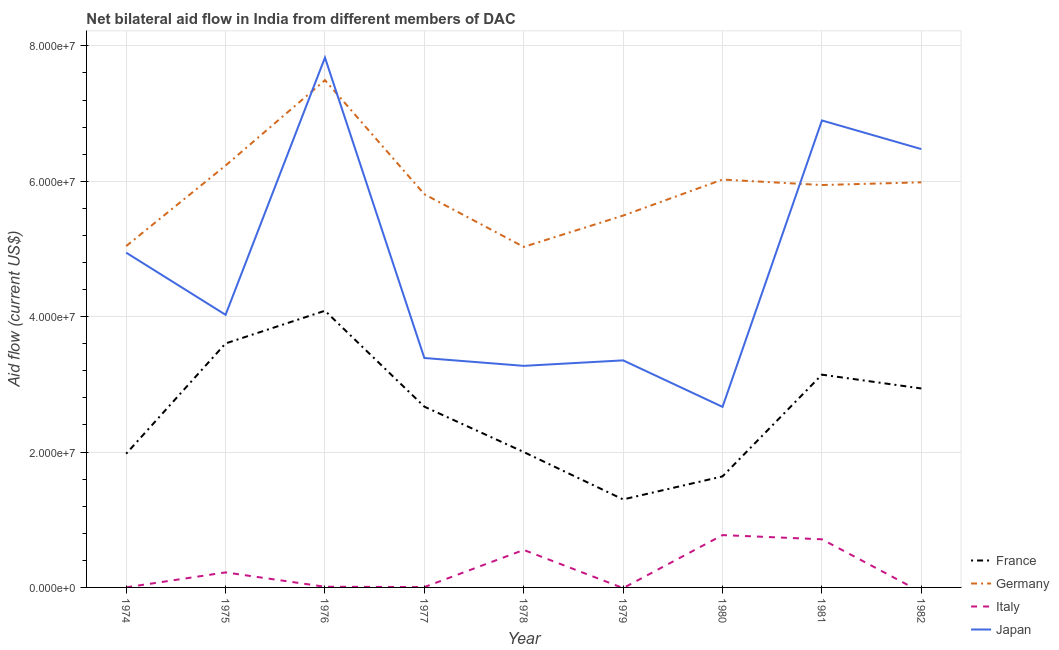What is the amount of aid given by germany in 1981?
Your answer should be compact. 5.94e+07. Across all years, what is the maximum amount of aid given by france?
Provide a succinct answer. 4.09e+07. Across all years, what is the minimum amount of aid given by france?
Your response must be concise. 1.30e+07. In which year was the amount of aid given by france maximum?
Offer a very short reply. 1976. What is the total amount of aid given by japan in the graph?
Make the answer very short. 4.29e+08. What is the difference between the amount of aid given by japan in 1978 and that in 1981?
Offer a terse response. -3.62e+07. What is the difference between the amount of aid given by italy in 1981 and the amount of aid given by germany in 1974?
Provide a short and direct response. -4.33e+07. What is the average amount of aid given by italy per year?
Provide a short and direct response. 2.53e+06. In the year 1979, what is the difference between the amount of aid given by japan and amount of aid given by germany?
Your answer should be very brief. -2.14e+07. In how many years, is the amount of aid given by france greater than 28000000 US$?
Provide a succinct answer. 4. What is the ratio of the amount of aid given by france in 1978 to that in 1979?
Your response must be concise. 1.54. Is the amount of aid given by germany in 1975 less than that in 1979?
Provide a succinct answer. No. What is the difference between the highest and the second highest amount of aid given by france?
Your response must be concise. 4.83e+06. What is the difference between the highest and the lowest amount of aid given by italy?
Your response must be concise. 7.73e+06. Is it the case that in every year, the sum of the amount of aid given by germany and amount of aid given by italy is greater than the sum of amount of aid given by france and amount of aid given by japan?
Your answer should be compact. No. Is it the case that in every year, the sum of the amount of aid given by france and amount of aid given by germany is greater than the amount of aid given by italy?
Offer a very short reply. Yes. Does the amount of aid given by italy monotonically increase over the years?
Your response must be concise. No. How many lines are there?
Make the answer very short. 4. How many years are there in the graph?
Your response must be concise. 9. Does the graph contain grids?
Keep it short and to the point. Yes. How are the legend labels stacked?
Your answer should be compact. Vertical. What is the title of the graph?
Your answer should be compact. Net bilateral aid flow in India from different members of DAC. What is the label or title of the Y-axis?
Keep it short and to the point. Aid flow (current US$). What is the Aid flow (current US$) in France in 1974?
Your answer should be very brief. 1.98e+07. What is the Aid flow (current US$) of Germany in 1974?
Your answer should be compact. 5.04e+07. What is the Aid flow (current US$) of Japan in 1974?
Provide a short and direct response. 4.94e+07. What is the Aid flow (current US$) in France in 1975?
Your answer should be compact. 3.60e+07. What is the Aid flow (current US$) of Germany in 1975?
Offer a very short reply. 6.23e+07. What is the Aid flow (current US$) in Italy in 1975?
Give a very brief answer. 2.22e+06. What is the Aid flow (current US$) of Japan in 1975?
Keep it short and to the point. 4.03e+07. What is the Aid flow (current US$) of France in 1976?
Ensure brevity in your answer.  4.09e+07. What is the Aid flow (current US$) of Germany in 1976?
Offer a terse response. 7.49e+07. What is the Aid flow (current US$) of Japan in 1976?
Offer a terse response. 7.83e+07. What is the Aid flow (current US$) in France in 1977?
Give a very brief answer. 2.67e+07. What is the Aid flow (current US$) in Germany in 1977?
Ensure brevity in your answer.  5.81e+07. What is the Aid flow (current US$) in Italy in 1977?
Keep it short and to the point. 5.00e+04. What is the Aid flow (current US$) in Japan in 1977?
Provide a short and direct response. 3.39e+07. What is the Aid flow (current US$) of Germany in 1978?
Keep it short and to the point. 5.03e+07. What is the Aid flow (current US$) of Italy in 1978?
Your answer should be compact. 5.54e+06. What is the Aid flow (current US$) in Japan in 1978?
Provide a succinct answer. 3.27e+07. What is the Aid flow (current US$) of France in 1979?
Your answer should be very brief. 1.30e+07. What is the Aid flow (current US$) in Germany in 1979?
Give a very brief answer. 5.49e+07. What is the Aid flow (current US$) of Italy in 1979?
Your response must be concise. 0. What is the Aid flow (current US$) in Japan in 1979?
Provide a succinct answer. 3.35e+07. What is the Aid flow (current US$) in France in 1980?
Your answer should be very brief. 1.64e+07. What is the Aid flow (current US$) in Germany in 1980?
Your answer should be very brief. 6.02e+07. What is the Aid flow (current US$) in Italy in 1980?
Your answer should be very brief. 7.73e+06. What is the Aid flow (current US$) in Japan in 1980?
Keep it short and to the point. 2.67e+07. What is the Aid flow (current US$) of France in 1981?
Make the answer very short. 3.14e+07. What is the Aid flow (current US$) in Germany in 1981?
Your answer should be very brief. 5.94e+07. What is the Aid flow (current US$) in Italy in 1981?
Your response must be concise. 7.11e+06. What is the Aid flow (current US$) in Japan in 1981?
Keep it short and to the point. 6.90e+07. What is the Aid flow (current US$) of France in 1982?
Keep it short and to the point. 2.94e+07. What is the Aid flow (current US$) of Germany in 1982?
Offer a very short reply. 5.98e+07. What is the Aid flow (current US$) in Japan in 1982?
Keep it short and to the point. 6.48e+07. Across all years, what is the maximum Aid flow (current US$) in France?
Offer a terse response. 4.09e+07. Across all years, what is the maximum Aid flow (current US$) of Germany?
Provide a succinct answer. 7.49e+07. Across all years, what is the maximum Aid flow (current US$) of Italy?
Give a very brief answer. 7.73e+06. Across all years, what is the maximum Aid flow (current US$) of Japan?
Ensure brevity in your answer.  7.83e+07. Across all years, what is the minimum Aid flow (current US$) of France?
Ensure brevity in your answer.  1.30e+07. Across all years, what is the minimum Aid flow (current US$) in Germany?
Offer a very short reply. 5.03e+07. Across all years, what is the minimum Aid flow (current US$) of Japan?
Offer a terse response. 2.67e+07. What is the total Aid flow (current US$) of France in the graph?
Ensure brevity in your answer.  2.34e+08. What is the total Aid flow (current US$) of Germany in the graph?
Provide a succinct answer. 5.31e+08. What is the total Aid flow (current US$) in Italy in the graph?
Offer a terse response. 2.28e+07. What is the total Aid flow (current US$) of Japan in the graph?
Ensure brevity in your answer.  4.29e+08. What is the difference between the Aid flow (current US$) in France in 1974 and that in 1975?
Provide a short and direct response. -1.63e+07. What is the difference between the Aid flow (current US$) in Germany in 1974 and that in 1975?
Provide a short and direct response. -1.19e+07. What is the difference between the Aid flow (current US$) in Italy in 1974 and that in 1975?
Provide a succinct answer. -2.21e+06. What is the difference between the Aid flow (current US$) in Japan in 1974 and that in 1975?
Your response must be concise. 9.18e+06. What is the difference between the Aid flow (current US$) of France in 1974 and that in 1976?
Provide a succinct answer. -2.11e+07. What is the difference between the Aid flow (current US$) in Germany in 1974 and that in 1976?
Keep it short and to the point. -2.45e+07. What is the difference between the Aid flow (current US$) in Italy in 1974 and that in 1976?
Keep it short and to the point. -9.00e+04. What is the difference between the Aid flow (current US$) in Japan in 1974 and that in 1976?
Keep it short and to the point. -2.88e+07. What is the difference between the Aid flow (current US$) of France in 1974 and that in 1977?
Provide a short and direct response. -6.95e+06. What is the difference between the Aid flow (current US$) in Germany in 1974 and that in 1977?
Keep it short and to the point. -7.66e+06. What is the difference between the Aid flow (current US$) of Italy in 1974 and that in 1977?
Offer a very short reply. -4.00e+04. What is the difference between the Aid flow (current US$) in Japan in 1974 and that in 1977?
Your response must be concise. 1.56e+07. What is the difference between the Aid flow (current US$) of Italy in 1974 and that in 1978?
Provide a succinct answer. -5.53e+06. What is the difference between the Aid flow (current US$) in Japan in 1974 and that in 1978?
Offer a terse response. 1.67e+07. What is the difference between the Aid flow (current US$) in France in 1974 and that in 1979?
Give a very brief answer. 6.75e+06. What is the difference between the Aid flow (current US$) in Germany in 1974 and that in 1979?
Give a very brief answer. -4.51e+06. What is the difference between the Aid flow (current US$) of Japan in 1974 and that in 1979?
Your answer should be very brief. 1.59e+07. What is the difference between the Aid flow (current US$) of France in 1974 and that in 1980?
Provide a short and direct response. 3.35e+06. What is the difference between the Aid flow (current US$) in Germany in 1974 and that in 1980?
Offer a terse response. -9.83e+06. What is the difference between the Aid flow (current US$) in Italy in 1974 and that in 1980?
Your response must be concise. -7.72e+06. What is the difference between the Aid flow (current US$) of Japan in 1974 and that in 1980?
Your answer should be compact. 2.28e+07. What is the difference between the Aid flow (current US$) in France in 1974 and that in 1981?
Ensure brevity in your answer.  -1.17e+07. What is the difference between the Aid flow (current US$) of Germany in 1974 and that in 1981?
Make the answer very short. -9.02e+06. What is the difference between the Aid flow (current US$) of Italy in 1974 and that in 1981?
Offer a terse response. -7.10e+06. What is the difference between the Aid flow (current US$) of Japan in 1974 and that in 1981?
Your answer should be very brief. -1.95e+07. What is the difference between the Aid flow (current US$) in France in 1974 and that in 1982?
Your answer should be compact. -9.64e+06. What is the difference between the Aid flow (current US$) in Germany in 1974 and that in 1982?
Your response must be concise. -9.42e+06. What is the difference between the Aid flow (current US$) of Japan in 1974 and that in 1982?
Give a very brief answer. -1.53e+07. What is the difference between the Aid flow (current US$) in France in 1975 and that in 1976?
Your answer should be compact. -4.83e+06. What is the difference between the Aid flow (current US$) of Germany in 1975 and that in 1976?
Offer a terse response. -1.26e+07. What is the difference between the Aid flow (current US$) of Italy in 1975 and that in 1976?
Provide a succinct answer. 2.12e+06. What is the difference between the Aid flow (current US$) in Japan in 1975 and that in 1976?
Ensure brevity in your answer.  -3.80e+07. What is the difference between the Aid flow (current US$) of France in 1975 and that in 1977?
Your answer should be very brief. 9.34e+06. What is the difference between the Aid flow (current US$) in Germany in 1975 and that in 1977?
Keep it short and to the point. 4.24e+06. What is the difference between the Aid flow (current US$) of Italy in 1975 and that in 1977?
Your response must be concise. 2.17e+06. What is the difference between the Aid flow (current US$) of Japan in 1975 and that in 1977?
Your answer should be compact. 6.38e+06. What is the difference between the Aid flow (current US$) of France in 1975 and that in 1978?
Keep it short and to the point. 1.60e+07. What is the difference between the Aid flow (current US$) in Germany in 1975 and that in 1978?
Offer a terse response. 1.20e+07. What is the difference between the Aid flow (current US$) of Italy in 1975 and that in 1978?
Give a very brief answer. -3.32e+06. What is the difference between the Aid flow (current US$) in Japan in 1975 and that in 1978?
Provide a succinct answer. 7.54e+06. What is the difference between the Aid flow (current US$) in France in 1975 and that in 1979?
Offer a very short reply. 2.30e+07. What is the difference between the Aid flow (current US$) of Germany in 1975 and that in 1979?
Your answer should be compact. 7.39e+06. What is the difference between the Aid flow (current US$) in Japan in 1975 and that in 1979?
Keep it short and to the point. 6.73e+06. What is the difference between the Aid flow (current US$) of France in 1975 and that in 1980?
Offer a terse response. 1.96e+07. What is the difference between the Aid flow (current US$) in Germany in 1975 and that in 1980?
Your answer should be very brief. 2.07e+06. What is the difference between the Aid flow (current US$) in Italy in 1975 and that in 1980?
Your answer should be very brief. -5.51e+06. What is the difference between the Aid flow (current US$) in Japan in 1975 and that in 1980?
Offer a terse response. 1.36e+07. What is the difference between the Aid flow (current US$) of France in 1975 and that in 1981?
Offer a terse response. 4.61e+06. What is the difference between the Aid flow (current US$) of Germany in 1975 and that in 1981?
Offer a terse response. 2.88e+06. What is the difference between the Aid flow (current US$) in Italy in 1975 and that in 1981?
Ensure brevity in your answer.  -4.89e+06. What is the difference between the Aid flow (current US$) in Japan in 1975 and that in 1981?
Your response must be concise. -2.87e+07. What is the difference between the Aid flow (current US$) of France in 1975 and that in 1982?
Ensure brevity in your answer.  6.65e+06. What is the difference between the Aid flow (current US$) in Germany in 1975 and that in 1982?
Your answer should be very brief. 2.48e+06. What is the difference between the Aid flow (current US$) of Japan in 1975 and that in 1982?
Offer a terse response. -2.45e+07. What is the difference between the Aid flow (current US$) of France in 1976 and that in 1977?
Keep it short and to the point. 1.42e+07. What is the difference between the Aid flow (current US$) of Germany in 1976 and that in 1977?
Offer a very short reply. 1.68e+07. What is the difference between the Aid flow (current US$) of Italy in 1976 and that in 1977?
Offer a terse response. 5.00e+04. What is the difference between the Aid flow (current US$) of Japan in 1976 and that in 1977?
Provide a succinct answer. 4.44e+07. What is the difference between the Aid flow (current US$) of France in 1976 and that in 1978?
Your answer should be very brief. 2.09e+07. What is the difference between the Aid flow (current US$) in Germany in 1976 and that in 1978?
Your response must be concise. 2.46e+07. What is the difference between the Aid flow (current US$) of Italy in 1976 and that in 1978?
Your response must be concise. -5.44e+06. What is the difference between the Aid flow (current US$) in Japan in 1976 and that in 1978?
Provide a short and direct response. 4.55e+07. What is the difference between the Aid flow (current US$) in France in 1976 and that in 1979?
Offer a very short reply. 2.79e+07. What is the difference between the Aid flow (current US$) of Japan in 1976 and that in 1979?
Provide a short and direct response. 4.47e+07. What is the difference between the Aid flow (current US$) in France in 1976 and that in 1980?
Offer a terse response. 2.45e+07. What is the difference between the Aid flow (current US$) in Germany in 1976 and that in 1980?
Your response must be concise. 1.47e+07. What is the difference between the Aid flow (current US$) in Italy in 1976 and that in 1980?
Your response must be concise. -7.63e+06. What is the difference between the Aid flow (current US$) in Japan in 1976 and that in 1980?
Provide a short and direct response. 5.16e+07. What is the difference between the Aid flow (current US$) in France in 1976 and that in 1981?
Give a very brief answer. 9.44e+06. What is the difference between the Aid flow (current US$) in Germany in 1976 and that in 1981?
Provide a short and direct response. 1.55e+07. What is the difference between the Aid flow (current US$) in Italy in 1976 and that in 1981?
Your answer should be very brief. -7.01e+06. What is the difference between the Aid flow (current US$) of Japan in 1976 and that in 1981?
Give a very brief answer. 9.29e+06. What is the difference between the Aid flow (current US$) of France in 1976 and that in 1982?
Your answer should be compact. 1.15e+07. What is the difference between the Aid flow (current US$) in Germany in 1976 and that in 1982?
Provide a short and direct response. 1.51e+07. What is the difference between the Aid flow (current US$) in Japan in 1976 and that in 1982?
Give a very brief answer. 1.35e+07. What is the difference between the Aid flow (current US$) of France in 1977 and that in 1978?
Offer a very short reply. 6.70e+06. What is the difference between the Aid flow (current US$) in Germany in 1977 and that in 1978?
Make the answer very short. 7.78e+06. What is the difference between the Aid flow (current US$) of Italy in 1977 and that in 1978?
Provide a short and direct response. -5.49e+06. What is the difference between the Aid flow (current US$) in Japan in 1977 and that in 1978?
Make the answer very short. 1.16e+06. What is the difference between the Aid flow (current US$) in France in 1977 and that in 1979?
Offer a very short reply. 1.37e+07. What is the difference between the Aid flow (current US$) in Germany in 1977 and that in 1979?
Provide a succinct answer. 3.15e+06. What is the difference between the Aid flow (current US$) in France in 1977 and that in 1980?
Offer a very short reply. 1.03e+07. What is the difference between the Aid flow (current US$) in Germany in 1977 and that in 1980?
Provide a succinct answer. -2.17e+06. What is the difference between the Aid flow (current US$) in Italy in 1977 and that in 1980?
Ensure brevity in your answer.  -7.68e+06. What is the difference between the Aid flow (current US$) in Japan in 1977 and that in 1980?
Provide a short and direct response. 7.22e+06. What is the difference between the Aid flow (current US$) in France in 1977 and that in 1981?
Make the answer very short. -4.73e+06. What is the difference between the Aid flow (current US$) of Germany in 1977 and that in 1981?
Your answer should be very brief. -1.36e+06. What is the difference between the Aid flow (current US$) in Italy in 1977 and that in 1981?
Provide a short and direct response. -7.06e+06. What is the difference between the Aid flow (current US$) of Japan in 1977 and that in 1981?
Your answer should be very brief. -3.51e+07. What is the difference between the Aid flow (current US$) in France in 1977 and that in 1982?
Provide a short and direct response. -2.69e+06. What is the difference between the Aid flow (current US$) of Germany in 1977 and that in 1982?
Provide a short and direct response. -1.76e+06. What is the difference between the Aid flow (current US$) of Japan in 1977 and that in 1982?
Keep it short and to the point. -3.09e+07. What is the difference between the Aid flow (current US$) of France in 1978 and that in 1979?
Provide a short and direct response. 7.00e+06. What is the difference between the Aid flow (current US$) of Germany in 1978 and that in 1979?
Provide a succinct answer. -4.63e+06. What is the difference between the Aid flow (current US$) in Japan in 1978 and that in 1979?
Make the answer very short. -8.10e+05. What is the difference between the Aid flow (current US$) in France in 1978 and that in 1980?
Provide a succinct answer. 3.60e+06. What is the difference between the Aid flow (current US$) in Germany in 1978 and that in 1980?
Provide a short and direct response. -9.95e+06. What is the difference between the Aid flow (current US$) of Italy in 1978 and that in 1980?
Keep it short and to the point. -2.19e+06. What is the difference between the Aid flow (current US$) of Japan in 1978 and that in 1980?
Offer a very short reply. 6.06e+06. What is the difference between the Aid flow (current US$) of France in 1978 and that in 1981?
Provide a succinct answer. -1.14e+07. What is the difference between the Aid flow (current US$) of Germany in 1978 and that in 1981?
Ensure brevity in your answer.  -9.14e+06. What is the difference between the Aid flow (current US$) of Italy in 1978 and that in 1981?
Your answer should be very brief. -1.57e+06. What is the difference between the Aid flow (current US$) of Japan in 1978 and that in 1981?
Make the answer very short. -3.62e+07. What is the difference between the Aid flow (current US$) of France in 1978 and that in 1982?
Your response must be concise. -9.39e+06. What is the difference between the Aid flow (current US$) in Germany in 1978 and that in 1982?
Provide a short and direct response. -9.54e+06. What is the difference between the Aid flow (current US$) of Japan in 1978 and that in 1982?
Your answer should be compact. -3.20e+07. What is the difference between the Aid flow (current US$) in France in 1979 and that in 1980?
Your answer should be very brief. -3.40e+06. What is the difference between the Aid flow (current US$) of Germany in 1979 and that in 1980?
Ensure brevity in your answer.  -5.32e+06. What is the difference between the Aid flow (current US$) in Japan in 1979 and that in 1980?
Offer a very short reply. 6.87e+06. What is the difference between the Aid flow (current US$) of France in 1979 and that in 1981?
Your answer should be very brief. -1.84e+07. What is the difference between the Aid flow (current US$) of Germany in 1979 and that in 1981?
Your answer should be compact. -4.51e+06. What is the difference between the Aid flow (current US$) in Japan in 1979 and that in 1981?
Ensure brevity in your answer.  -3.54e+07. What is the difference between the Aid flow (current US$) in France in 1979 and that in 1982?
Give a very brief answer. -1.64e+07. What is the difference between the Aid flow (current US$) of Germany in 1979 and that in 1982?
Your response must be concise. -4.91e+06. What is the difference between the Aid flow (current US$) in Japan in 1979 and that in 1982?
Make the answer very short. -3.12e+07. What is the difference between the Aid flow (current US$) in France in 1980 and that in 1981?
Offer a terse response. -1.50e+07. What is the difference between the Aid flow (current US$) in Germany in 1980 and that in 1981?
Give a very brief answer. 8.10e+05. What is the difference between the Aid flow (current US$) in Italy in 1980 and that in 1981?
Your answer should be compact. 6.20e+05. What is the difference between the Aid flow (current US$) in Japan in 1980 and that in 1981?
Provide a short and direct response. -4.23e+07. What is the difference between the Aid flow (current US$) of France in 1980 and that in 1982?
Offer a terse response. -1.30e+07. What is the difference between the Aid flow (current US$) of Germany in 1980 and that in 1982?
Your answer should be compact. 4.10e+05. What is the difference between the Aid flow (current US$) of Japan in 1980 and that in 1982?
Give a very brief answer. -3.81e+07. What is the difference between the Aid flow (current US$) in France in 1981 and that in 1982?
Offer a terse response. 2.04e+06. What is the difference between the Aid flow (current US$) in Germany in 1981 and that in 1982?
Offer a very short reply. -4.00e+05. What is the difference between the Aid flow (current US$) in Japan in 1981 and that in 1982?
Your response must be concise. 4.23e+06. What is the difference between the Aid flow (current US$) of France in 1974 and the Aid flow (current US$) of Germany in 1975?
Keep it short and to the point. -4.26e+07. What is the difference between the Aid flow (current US$) of France in 1974 and the Aid flow (current US$) of Italy in 1975?
Provide a succinct answer. 1.75e+07. What is the difference between the Aid flow (current US$) of France in 1974 and the Aid flow (current US$) of Japan in 1975?
Ensure brevity in your answer.  -2.05e+07. What is the difference between the Aid flow (current US$) of Germany in 1974 and the Aid flow (current US$) of Italy in 1975?
Keep it short and to the point. 4.82e+07. What is the difference between the Aid flow (current US$) in Germany in 1974 and the Aid flow (current US$) in Japan in 1975?
Provide a succinct answer. 1.02e+07. What is the difference between the Aid flow (current US$) of Italy in 1974 and the Aid flow (current US$) of Japan in 1975?
Give a very brief answer. -4.03e+07. What is the difference between the Aid flow (current US$) in France in 1974 and the Aid flow (current US$) in Germany in 1976?
Your answer should be very brief. -5.52e+07. What is the difference between the Aid flow (current US$) in France in 1974 and the Aid flow (current US$) in Italy in 1976?
Offer a terse response. 1.96e+07. What is the difference between the Aid flow (current US$) in France in 1974 and the Aid flow (current US$) in Japan in 1976?
Provide a short and direct response. -5.85e+07. What is the difference between the Aid flow (current US$) in Germany in 1974 and the Aid flow (current US$) in Italy in 1976?
Provide a short and direct response. 5.03e+07. What is the difference between the Aid flow (current US$) in Germany in 1974 and the Aid flow (current US$) in Japan in 1976?
Ensure brevity in your answer.  -2.78e+07. What is the difference between the Aid flow (current US$) of Italy in 1974 and the Aid flow (current US$) of Japan in 1976?
Make the answer very short. -7.83e+07. What is the difference between the Aid flow (current US$) in France in 1974 and the Aid flow (current US$) in Germany in 1977?
Keep it short and to the point. -3.83e+07. What is the difference between the Aid flow (current US$) in France in 1974 and the Aid flow (current US$) in Italy in 1977?
Your response must be concise. 1.97e+07. What is the difference between the Aid flow (current US$) of France in 1974 and the Aid flow (current US$) of Japan in 1977?
Provide a short and direct response. -1.41e+07. What is the difference between the Aid flow (current US$) of Germany in 1974 and the Aid flow (current US$) of Italy in 1977?
Keep it short and to the point. 5.04e+07. What is the difference between the Aid flow (current US$) of Germany in 1974 and the Aid flow (current US$) of Japan in 1977?
Offer a very short reply. 1.65e+07. What is the difference between the Aid flow (current US$) of Italy in 1974 and the Aid flow (current US$) of Japan in 1977?
Give a very brief answer. -3.39e+07. What is the difference between the Aid flow (current US$) in France in 1974 and the Aid flow (current US$) in Germany in 1978?
Your answer should be compact. -3.06e+07. What is the difference between the Aid flow (current US$) of France in 1974 and the Aid flow (current US$) of Italy in 1978?
Give a very brief answer. 1.42e+07. What is the difference between the Aid flow (current US$) of France in 1974 and the Aid flow (current US$) of Japan in 1978?
Provide a succinct answer. -1.30e+07. What is the difference between the Aid flow (current US$) in Germany in 1974 and the Aid flow (current US$) in Italy in 1978?
Provide a succinct answer. 4.49e+07. What is the difference between the Aid flow (current US$) in Germany in 1974 and the Aid flow (current US$) in Japan in 1978?
Keep it short and to the point. 1.77e+07. What is the difference between the Aid flow (current US$) of Italy in 1974 and the Aid flow (current US$) of Japan in 1978?
Offer a terse response. -3.27e+07. What is the difference between the Aid flow (current US$) of France in 1974 and the Aid flow (current US$) of Germany in 1979?
Your answer should be compact. -3.52e+07. What is the difference between the Aid flow (current US$) of France in 1974 and the Aid flow (current US$) of Japan in 1979?
Your response must be concise. -1.38e+07. What is the difference between the Aid flow (current US$) in Germany in 1974 and the Aid flow (current US$) in Japan in 1979?
Your answer should be very brief. 1.69e+07. What is the difference between the Aid flow (current US$) in Italy in 1974 and the Aid flow (current US$) in Japan in 1979?
Provide a succinct answer. -3.35e+07. What is the difference between the Aid flow (current US$) of France in 1974 and the Aid flow (current US$) of Germany in 1980?
Make the answer very short. -4.05e+07. What is the difference between the Aid flow (current US$) of France in 1974 and the Aid flow (current US$) of Italy in 1980?
Offer a very short reply. 1.20e+07. What is the difference between the Aid flow (current US$) in France in 1974 and the Aid flow (current US$) in Japan in 1980?
Provide a succinct answer. -6.92e+06. What is the difference between the Aid flow (current US$) of Germany in 1974 and the Aid flow (current US$) of Italy in 1980?
Offer a very short reply. 4.27e+07. What is the difference between the Aid flow (current US$) of Germany in 1974 and the Aid flow (current US$) of Japan in 1980?
Ensure brevity in your answer.  2.38e+07. What is the difference between the Aid flow (current US$) of Italy in 1974 and the Aid flow (current US$) of Japan in 1980?
Provide a short and direct response. -2.67e+07. What is the difference between the Aid flow (current US$) in France in 1974 and the Aid flow (current US$) in Germany in 1981?
Your answer should be compact. -3.97e+07. What is the difference between the Aid flow (current US$) in France in 1974 and the Aid flow (current US$) in Italy in 1981?
Your answer should be very brief. 1.26e+07. What is the difference between the Aid flow (current US$) in France in 1974 and the Aid flow (current US$) in Japan in 1981?
Offer a terse response. -4.92e+07. What is the difference between the Aid flow (current US$) of Germany in 1974 and the Aid flow (current US$) of Italy in 1981?
Give a very brief answer. 4.33e+07. What is the difference between the Aid flow (current US$) in Germany in 1974 and the Aid flow (current US$) in Japan in 1981?
Your answer should be compact. -1.86e+07. What is the difference between the Aid flow (current US$) of Italy in 1974 and the Aid flow (current US$) of Japan in 1981?
Offer a very short reply. -6.90e+07. What is the difference between the Aid flow (current US$) of France in 1974 and the Aid flow (current US$) of Germany in 1982?
Offer a very short reply. -4.01e+07. What is the difference between the Aid flow (current US$) of France in 1974 and the Aid flow (current US$) of Japan in 1982?
Ensure brevity in your answer.  -4.50e+07. What is the difference between the Aid flow (current US$) in Germany in 1974 and the Aid flow (current US$) in Japan in 1982?
Your answer should be very brief. -1.43e+07. What is the difference between the Aid flow (current US$) of Italy in 1974 and the Aid flow (current US$) of Japan in 1982?
Your response must be concise. -6.47e+07. What is the difference between the Aid flow (current US$) in France in 1975 and the Aid flow (current US$) in Germany in 1976?
Provide a succinct answer. -3.89e+07. What is the difference between the Aid flow (current US$) of France in 1975 and the Aid flow (current US$) of Italy in 1976?
Ensure brevity in your answer.  3.59e+07. What is the difference between the Aid flow (current US$) in France in 1975 and the Aid flow (current US$) in Japan in 1976?
Offer a very short reply. -4.22e+07. What is the difference between the Aid flow (current US$) in Germany in 1975 and the Aid flow (current US$) in Italy in 1976?
Your answer should be compact. 6.22e+07. What is the difference between the Aid flow (current US$) of Germany in 1975 and the Aid flow (current US$) of Japan in 1976?
Provide a succinct answer. -1.60e+07. What is the difference between the Aid flow (current US$) in Italy in 1975 and the Aid flow (current US$) in Japan in 1976?
Your answer should be very brief. -7.60e+07. What is the difference between the Aid flow (current US$) of France in 1975 and the Aid flow (current US$) of Germany in 1977?
Make the answer very short. -2.20e+07. What is the difference between the Aid flow (current US$) of France in 1975 and the Aid flow (current US$) of Italy in 1977?
Your answer should be very brief. 3.60e+07. What is the difference between the Aid flow (current US$) of France in 1975 and the Aid flow (current US$) of Japan in 1977?
Provide a succinct answer. 2.15e+06. What is the difference between the Aid flow (current US$) in Germany in 1975 and the Aid flow (current US$) in Italy in 1977?
Give a very brief answer. 6.23e+07. What is the difference between the Aid flow (current US$) in Germany in 1975 and the Aid flow (current US$) in Japan in 1977?
Give a very brief answer. 2.84e+07. What is the difference between the Aid flow (current US$) in Italy in 1975 and the Aid flow (current US$) in Japan in 1977?
Ensure brevity in your answer.  -3.17e+07. What is the difference between the Aid flow (current US$) in France in 1975 and the Aid flow (current US$) in Germany in 1978?
Ensure brevity in your answer.  -1.43e+07. What is the difference between the Aid flow (current US$) of France in 1975 and the Aid flow (current US$) of Italy in 1978?
Give a very brief answer. 3.05e+07. What is the difference between the Aid flow (current US$) of France in 1975 and the Aid flow (current US$) of Japan in 1978?
Your answer should be very brief. 3.31e+06. What is the difference between the Aid flow (current US$) of Germany in 1975 and the Aid flow (current US$) of Italy in 1978?
Your response must be concise. 5.68e+07. What is the difference between the Aid flow (current US$) in Germany in 1975 and the Aid flow (current US$) in Japan in 1978?
Offer a very short reply. 2.96e+07. What is the difference between the Aid flow (current US$) in Italy in 1975 and the Aid flow (current US$) in Japan in 1978?
Provide a short and direct response. -3.05e+07. What is the difference between the Aid flow (current US$) in France in 1975 and the Aid flow (current US$) in Germany in 1979?
Provide a succinct answer. -1.89e+07. What is the difference between the Aid flow (current US$) of France in 1975 and the Aid flow (current US$) of Japan in 1979?
Provide a succinct answer. 2.50e+06. What is the difference between the Aid flow (current US$) of Germany in 1975 and the Aid flow (current US$) of Japan in 1979?
Offer a very short reply. 2.88e+07. What is the difference between the Aid flow (current US$) in Italy in 1975 and the Aid flow (current US$) in Japan in 1979?
Ensure brevity in your answer.  -3.13e+07. What is the difference between the Aid flow (current US$) in France in 1975 and the Aid flow (current US$) in Germany in 1980?
Ensure brevity in your answer.  -2.42e+07. What is the difference between the Aid flow (current US$) of France in 1975 and the Aid flow (current US$) of Italy in 1980?
Provide a succinct answer. 2.83e+07. What is the difference between the Aid flow (current US$) of France in 1975 and the Aid flow (current US$) of Japan in 1980?
Your answer should be compact. 9.37e+06. What is the difference between the Aid flow (current US$) of Germany in 1975 and the Aid flow (current US$) of Italy in 1980?
Offer a terse response. 5.46e+07. What is the difference between the Aid flow (current US$) of Germany in 1975 and the Aid flow (current US$) of Japan in 1980?
Ensure brevity in your answer.  3.56e+07. What is the difference between the Aid flow (current US$) in Italy in 1975 and the Aid flow (current US$) in Japan in 1980?
Give a very brief answer. -2.44e+07. What is the difference between the Aid flow (current US$) in France in 1975 and the Aid flow (current US$) in Germany in 1981?
Your answer should be compact. -2.34e+07. What is the difference between the Aid flow (current US$) in France in 1975 and the Aid flow (current US$) in Italy in 1981?
Provide a succinct answer. 2.89e+07. What is the difference between the Aid flow (current US$) in France in 1975 and the Aid flow (current US$) in Japan in 1981?
Ensure brevity in your answer.  -3.29e+07. What is the difference between the Aid flow (current US$) of Germany in 1975 and the Aid flow (current US$) of Italy in 1981?
Your answer should be very brief. 5.52e+07. What is the difference between the Aid flow (current US$) in Germany in 1975 and the Aid flow (current US$) in Japan in 1981?
Offer a very short reply. -6.66e+06. What is the difference between the Aid flow (current US$) of Italy in 1975 and the Aid flow (current US$) of Japan in 1981?
Your answer should be very brief. -6.68e+07. What is the difference between the Aid flow (current US$) in France in 1975 and the Aid flow (current US$) in Germany in 1982?
Provide a succinct answer. -2.38e+07. What is the difference between the Aid flow (current US$) in France in 1975 and the Aid flow (current US$) in Japan in 1982?
Give a very brief answer. -2.87e+07. What is the difference between the Aid flow (current US$) of Germany in 1975 and the Aid flow (current US$) of Japan in 1982?
Offer a terse response. -2.43e+06. What is the difference between the Aid flow (current US$) of Italy in 1975 and the Aid flow (current US$) of Japan in 1982?
Keep it short and to the point. -6.25e+07. What is the difference between the Aid flow (current US$) of France in 1976 and the Aid flow (current US$) of Germany in 1977?
Your response must be concise. -1.72e+07. What is the difference between the Aid flow (current US$) in France in 1976 and the Aid flow (current US$) in Italy in 1977?
Your answer should be compact. 4.08e+07. What is the difference between the Aid flow (current US$) of France in 1976 and the Aid flow (current US$) of Japan in 1977?
Provide a short and direct response. 6.98e+06. What is the difference between the Aid flow (current US$) of Germany in 1976 and the Aid flow (current US$) of Italy in 1977?
Your answer should be very brief. 7.49e+07. What is the difference between the Aid flow (current US$) of Germany in 1976 and the Aid flow (current US$) of Japan in 1977?
Your answer should be compact. 4.10e+07. What is the difference between the Aid flow (current US$) of Italy in 1976 and the Aid flow (current US$) of Japan in 1977?
Make the answer very short. -3.38e+07. What is the difference between the Aid flow (current US$) in France in 1976 and the Aid flow (current US$) in Germany in 1978?
Provide a short and direct response. -9.43e+06. What is the difference between the Aid flow (current US$) in France in 1976 and the Aid flow (current US$) in Italy in 1978?
Offer a very short reply. 3.53e+07. What is the difference between the Aid flow (current US$) of France in 1976 and the Aid flow (current US$) of Japan in 1978?
Keep it short and to the point. 8.14e+06. What is the difference between the Aid flow (current US$) in Germany in 1976 and the Aid flow (current US$) in Italy in 1978?
Provide a short and direct response. 6.94e+07. What is the difference between the Aid flow (current US$) in Germany in 1976 and the Aid flow (current US$) in Japan in 1978?
Provide a short and direct response. 4.22e+07. What is the difference between the Aid flow (current US$) in Italy in 1976 and the Aid flow (current US$) in Japan in 1978?
Provide a succinct answer. -3.26e+07. What is the difference between the Aid flow (current US$) in France in 1976 and the Aid flow (current US$) in Germany in 1979?
Your response must be concise. -1.41e+07. What is the difference between the Aid flow (current US$) in France in 1976 and the Aid flow (current US$) in Japan in 1979?
Keep it short and to the point. 7.33e+06. What is the difference between the Aid flow (current US$) in Germany in 1976 and the Aid flow (current US$) in Japan in 1979?
Ensure brevity in your answer.  4.14e+07. What is the difference between the Aid flow (current US$) of Italy in 1976 and the Aid flow (current US$) of Japan in 1979?
Give a very brief answer. -3.34e+07. What is the difference between the Aid flow (current US$) of France in 1976 and the Aid flow (current US$) of Germany in 1980?
Your answer should be very brief. -1.94e+07. What is the difference between the Aid flow (current US$) in France in 1976 and the Aid flow (current US$) in Italy in 1980?
Ensure brevity in your answer.  3.31e+07. What is the difference between the Aid flow (current US$) of France in 1976 and the Aid flow (current US$) of Japan in 1980?
Keep it short and to the point. 1.42e+07. What is the difference between the Aid flow (current US$) of Germany in 1976 and the Aid flow (current US$) of Italy in 1980?
Your answer should be compact. 6.72e+07. What is the difference between the Aid flow (current US$) of Germany in 1976 and the Aid flow (current US$) of Japan in 1980?
Your answer should be compact. 4.83e+07. What is the difference between the Aid flow (current US$) of Italy in 1976 and the Aid flow (current US$) of Japan in 1980?
Ensure brevity in your answer.  -2.66e+07. What is the difference between the Aid flow (current US$) in France in 1976 and the Aid flow (current US$) in Germany in 1981?
Offer a terse response. -1.86e+07. What is the difference between the Aid flow (current US$) in France in 1976 and the Aid flow (current US$) in Italy in 1981?
Your answer should be compact. 3.38e+07. What is the difference between the Aid flow (current US$) in France in 1976 and the Aid flow (current US$) in Japan in 1981?
Offer a very short reply. -2.81e+07. What is the difference between the Aid flow (current US$) of Germany in 1976 and the Aid flow (current US$) of Italy in 1981?
Your answer should be compact. 6.78e+07. What is the difference between the Aid flow (current US$) in Germany in 1976 and the Aid flow (current US$) in Japan in 1981?
Provide a succinct answer. 5.95e+06. What is the difference between the Aid flow (current US$) in Italy in 1976 and the Aid flow (current US$) in Japan in 1981?
Your response must be concise. -6.89e+07. What is the difference between the Aid flow (current US$) of France in 1976 and the Aid flow (current US$) of Germany in 1982?
Provide a succinct answer. -1.90e+07. What is the difference between the Aid flow (current US$) in France in 1976 and the Aid flow (current US$) in Japan in 1982?
Your answer should be compact. -2.39e+07. What is the difference between the Aid flow (current US$) in Germany in 1976 and the Aid flow (current US$) in Japan in 1982?
Ensure brevity in your answer.  1.02e+07. What is the difference between the Aid flow (current US$) in Italy in 1976 and the Aid flow (current US$) in Japan in 1982?
Offer a very short reply. -6.46e+07. What is the difference between the Aid flow (current US$) of France in 1977 and the Aid flow (current US$) of Germany in 1978?
Provide a succinct answer. -2.36e+07. What is the difference between the Aid flow (current US$) in France in 1977 and the Aid flow (current US$) in Italy in 1978?
Offer a very short reply. 2.12e+07. What is the difference between the Aid flow (current US$) in France in 1977 and the Aid flow (current US$) in Japan in 1978?
Make the answer very short. -6.03e+06. What is the difference between the Aid flow (current US$) in Germany in 1977 and the Aid flow (current US$) in Italy in 1978?
Your answer should be very brief. 5.25e+07. What is the difference between the Aid flow (current US$) of Germany in 1977 and the Aid flow (current US$) of Japan in 1978?
Provide a short and direct response. 2.54e+07. What is the difference between the Aid flow (current US$) of Italy in 1977 and the Aid flow (current US$) of Japan in 1978?
Give a very brief answer. -3.27e+07. What is the difference between the Aid flow (current US$) in France in 1977 and the Aid flow (current US$) in Germany in 1979?
Ensure brevity in your answer.  -2.82e+07. What is the difference between the Aid flow (current US$) in France in 1977 and the Aid flow (current US$) in Japan in 1979?
Ensure brevity in your answer.  -6.84e+06. What is the difference between the Aid flow (current US$) of Germany in 1977 and the Aid flow (current US$) of Japan in 1979?
Offer a very short reply. 2.45e+07. What is the difference between the Aid flow (current US$) in Italy in 1977 and the Aid flow (current US$) in Japan in 1979?
Your response must be concise. -3.35e+07. What is the difference between the Aid flow (current US$) of France in 1977 and the Aid flow (current US$) of Germany in 1980?
Provide a short and direct response. -3.36e+07. What is the difference between the Aid flow (current US$) of France in 1977 and the Aid flow (current US$) of Italy in 1980?
Ensure brevity in your answer.  1.90e+07. What is the difference between the Aid flow (current US$) in Germany in 1977 and the Aid flow (current US$) in Italy in 1980?
Your answer should be very brief. 5.04e+07. What is the difference between the Aid flow (current US$) of Germany in 1977 and the Aid flow (current US$) of Japan in 1980?
Your response must be concise. 3.14e+07. What is the difference between the Aid flow (current US$) of Italy in 1977 and the Aid flow (current US$) of Japan in 1980?
Your answer should be very brief. -2.66e+07. What is the difference between the Aid flow (current US$) of France in 1977 and the Aid flow (current US$) of Germany in 1981?
Offer a terse response. -3.27e+07. What is the difference between the Aid flow (current US$) in France in 1977 and the Aid flow (current US$) in Italy in 1981?
Ensure brevity in your answer.  1.96e+07. What is the difference between the Aid flow (current US$) in France in 1977 and the Aid flow (current US$) in Japan in 1981?
Your response must be concise. -4.23e+07. What is the difference between the Aid flow (current US$) of Germany in 1977 and the Aid flow (current US$) of Italy in 1981?
Offer a very short reply. 5.10e+07. What is the difference between the Aid flow (current US$) of Germany in 1977 and the Aid flow (current US$) of Japan in 1981?
Offer a terse response. -1.09e+07. What is the difference between the Aid flow (current US$) of Italy in 1977 and the Aid flow (current US$) of Japan in 1981?
Keep it short and to the point. -6.89e+07. What is the difference between the Aid flow (current US$) of France in 1977 and the Aid flow (current US$) of Germany in 1982?
Your answer should be very brief. -3.31e+07. What is the difference between the Aid flow (current US$) in France in 1977 and the Aid flow (current US$) in Japan in 1982?
Make the answer very short. -3.80e+07. What is the difference between the Aid flow (current US$) of Germany in 1977 and the Aid flow (current US$) of Japan in 1982?
Ensure brevity in your answer.  -6.67e+06. What is the difference between the Aid flow (current US$) of Italy in 1977 and the Aid flow (current US$) of Japan in 1982?
Provide a succinct answer. -6.47e+07. What is the difference between the Aid flow (current US$) in France in 1978 and the Aid flow (current US$) in Germany in 1979?
Ensure brevity in your answer.  -3.49e+07. What is the difference between the Aid flow (current US$) in France in 1978 and the Aid flow (current US$) in Japan in 1979?
Make the answer very short. -1.35e+07. What is the difference between the Aid flow (current US$) in Germany in 1978 and the Aid flow (current US$) in Japan in 1979?
Your answer should be very brief. 1.68e+07. What is the difference between the Aid flow (current US$) in Italy in 1978 and the Aid flow (current US$) in Japan in 1979?
Make the answer very short. -2.80e+07. What is the difference between the Aid flow (current US$) in France in 1978 and the Aid flow (current US$) in Germany in 1980?
Provide a short and direct response. -4.02e+07. What is the difference between the Aid flow (current US$) in France in 1978 and the Aid flow (current US$) in Italy in 1980?
Provide a short and direct response. 1.23e+07. What is the difference between the Aid flow (current US$) of France in 1978 and the Aid flow (current US$) of Japan in 1980?
Your response must be concise. -6.67e+06. What is the difference between the Aid flow (current US$) of Germany in 1978 and the Aid flow (current US$) of Italy in 1980?
Your answer should be very brief. 4.26e+07. What is the difference between the Aid flow (current US$) in Germany in 1978 and the Aid flow (current US$) in Japan in 1980?
Offer a terse response. 2.36e+07. What is the difference between the Aid flow (current US$) in Italy in 1978 and the Aid flow (current US$) in Japan in 1980?
Ensure brevity in your answer.  -2.11e+07. What is the difference between the Aid flow (current US$) in France in 1978 and the Aid flow (current US$) in Germany in 1981?
Ensure brevity in your answer.  -3.94e+07. What is the difference between the Aid flow (current US$) of France in 1978 and the Aid flow (current US$) of Italy in 1981?
Your answer should be compact. 1.29e+07. What is the difference between the Aid flow (current US$) of France in 1978 and the Aid flow (current US$) of Japan in 1981?
Give a very brief answer. -4.90e+07. What is the difference between the Aid flow (current US$) of Germany in 1978 and the Aid flow (current US$) of Italy in 1981?
Your answer should be compact. 4.32e+07. What is the difference between the Aid flow (current US$) in Germany in 1978 and the Aid flow (current US$) in Japan in 1981?
Your answer should be compact. -1.87e+07. What is the difference between the Aid flow (current US$) in Italy in 1978 and the Aid flow (current US$) in Japan in 1981?
Offer a terse response. -6.34e+07. What is the difference between the Aid flow (current US$) of France in 1978 and the Aid flow (current US$) of Germany in 1982?
Your response must be concise. -3.98e+07. What is the difference between the Aid flow (current US$) of France in 1978 and the Aid flow (current US$) of Japan in 1982?
Offer a terse response. -4.48e+07. What is the difference between the Aid flow (current US$) in Germany in 1978 and the Aid flow (current US$) in Japan in 1982?
Your answer should be compact. -1.44e+07. What is the difference between the Aid flow (current US$) of Italy in 1978 and the Aid flow (current US$) of Japan in 1982?
Keep it short and to the point. -5.92e+07. What is the difference between the Aid flow (current US$) in France in 1979 and the Aid flow (current US$) in Germany in 1980?
Your response must be concise. -4.72e+07. What is the difference between the Aid flow (current US$) of France in 1979 and the Aid flow (current US$) of Italy in 1980?
Ensure brevity in your answer.  5.27e+06. What is the difference between the Aid flow (current US$) of France in 1979 and the Aid flow (current US$) of Japan in 1980?
Offer a very short reply. -1.37e+07. What is the difference between the Aid flow (current US$) in Germany in 1979 and the Aid flow (current US$) in Italy in 1980?
Your answer should be very brief. 4.72e+07. What is the difference between the Aid flow (current US$) of Germany in 1979 and the Aid flow (current US$) of Japan in 1980?
Provide a succinct answer. 2.83e+07. What is the difference between the Aid flow (current US$) in France in 1979 and the Aid flow (current US$) in Germany in 1981?
Offer a terse response. -4.64e+07. What is the difference between the Aid flow (current US$) in France in 1979 and the Aid flow (current US$) in Italy in 1981?
Give a very brief answer. 5.89e+06. What is the difference between the Aid flow (current US$) in France in 1979 and the Aid flow (current US$) in Japan in 1981?
Keep it short and to the point. -5.60e+07. What is the difference between the Aid flow (current US$) in Germany in 1979 and the Aid flow (current US$) in Italy in 1981?
Ensure brevity in your answer.  4.78e+07. What is the difference between the Aid flow (current US$) in Germany in 1979 and the Aid flow (current US$) in Japan in 1981?
Give a very brief answer. -1.40e+07. What is the difference between the Aid flow (current US$) of France in 1979 and the Aid flow (current US$) of Germany in 1982?
Give a very brief answer. -4.68e+07. What is the difference between the Aid flow (current US$) in France in 1979 and the Aid flow (current US$) in Japan in 1982?
Keep it short and to the point. -5.18e+07. What is the difference between the Aid flow (current US$) in Germany in 1979 and the Aid flow (current US$) in Japan in 1982?
Provide a succinct answer. -9.82e+06. What is the difference between the Aid flow (current US$) in France in 1980 and the Aid flow (current US$) in Germany in 1981?
Your answer should be compact. -4.30e+07. What is the difference between the Aid flow (current US$) of France in 1980 and the Aid flow (current US$) of Italy in 1981?
Your answer should be very brief. 9.29e+06. What is the difference between the Aid flow (current US$) of France in 1980 and the Aid flow (current US$) of Japan in 1981?
Your answer should be compact. -5.26e+07. What is the difference between the Aid flow (current US$) in Germany in 1980 and the Aid flow (current US$) in Italy in 1981?
Your response must be concise. 5.31e+07. What is the difference between the Aid flow (current US$) of Germany in 1980 and the Aid flow (current US$) of Japan in 1981?
Ensure brevity in your answer.  -8.73e+06. What is the difference between the Aid flow (current US$) of Italy in 1980 and the Aid flow (current US$) of Japan in 1981?
Offer a very short reply. -6.12e+07. What is the difference between the Aid flow (current US$) in France in 1980 and the Aid flow (current US$) in Germany in 1982?
Ensure brevity in your answer.  -4.34e+07. What is the difference between the Aid flow (current US$) in France in 1980 and the Aid flow (current US$) in Japan in 1982?
Your answer should be compact. -4.84e+07. What is the difference between the Aid flow (current US$) of Germany in 1980 and the Aid flow (current US$) of Japan in 1982?
Provide a succinct answer. -4.50e+06. What is the difference between the Aid flow (current US$) in Italy in 1980 and the Aid flow (current US$) in Japan in 1982?
Your response must be concise. -5.70e+07. What is the difference between the Aid flow (current US$) in France in 1981 and the Aid flow (current US$) in Germany in 1982?
Your response must be concise. -2.84e+07. What is the difference between the Aid flow (current US$) in France in 1981 and the Aid flow (current US$) in Japan in 1982?
Your response must be concise. -3.33e+07. What is the difference between the Aid flow (current US$) of Germany in 1981 and the Aid flow (current US$) of Japan in 1982?
Provide a short and direct response. -5.31e+06. What is the difference between the Aid flow (current US$) of Italy in 1981 and the Aid flow (current US$) of Japan in 1982?
Offer a very short reply. -5.76e+07. What is the average Aid flow (current US$) of France per year?
Ensure brevity in your answer.  2.60e+07. What is the average Aid flow (current US$) in Germany per year?
Ensure brevity in your answer.  5.89e+07. What is the average Aid flow (current US$) of Italy per year?
Ensure brevity in your answer.  2.53e+06. What is the average Aid flow (current US$) in Japan per year?
Ensure brevity in your answer.  4.76e+07. In the year 1974, what is the difference between the Aid flow (current US$) of France and Aid flow (current US$) of Germany?
Make the answer very short. -3.07e+07. In the year 1974, what is the difference between the Aid flow (current US$) of France and Aid flow (current US$) of Italy?
Make the answer very short. 1.97e+07. In the year 1974, what is the difference between the Aid flow (current US$) of France and Aid flow (current US$) of Japan?
Provide a short and direct response. -2.97e+07. In the year 1974, what is the difference between the Aid flow (current US$) of Germany and Aid flow (current US$) of Italy?
Provide a succinct answer. 5.04e+07. In the year 1974, what is the difference between the Aid flow (current US$) of Germany and Aid flow (current US$) of Japan?
Your response must be concise. 9.70e+05. In the year 1974, what is the difference between the Aid flow (current US$) of Italy and Aid flow (current US$) of Japan?
Your answer should be very brief. -4.94e+07. In the year 1975, what is the difference between the Aid flow (current US$) in France and Aid flow (current US$) in Germany?
Make the answer very short. -2.63e+07. In the year 1975, what is the difference between the Aid flow (current US$) of France and Aid flow (current US$) of Italy?
Offer a very short reply. 3.38e+07. In the year 1975, what is the difference between the Aid flow (current US$) of France and Aid flow (current US$) of Japan?
Ensure brevity in your answer.  -4.23e+06. In the year 1975, what is the difference between the Aid flow (current US$) in Germany and Aid flow (current US$) in Italy?
Your answer should be compact. 6.01e+07. In the year 1975, what is the difference between the Aid flow (current US$) of Germany and Aid flow (current US$) of Japan?
Offer a very short reply. 2.20e+07. In the year 1975, what is the difference between the Aid flow (current US$) in Italy and Aid flow (current US$) in Japan?
Give a very brief answer. -3.80e+07. In the year 1976, what is the difference between the Aid flow (current US$) in France and Aid flow (current US$) in Germany?
Give a very brief answer. -3.41e+07. In the year 1976, what is the difference between the Aid flow (current US$) in France and Aid flow (current US$) in Italy?
Provide a short and direct response. 4.08e+07. In the year 1976, what is the difference between the Aid flow (current US$) of France and Aid flow (current US$) of Japan?
Your response must be concise. -3.74e+07. In the year 1976, what is the difference between the Aid flow (current US$) of Germany and Aid flow (current US$) of Italy?
Your response must be concise. 7.48e+07. In the year 1976, what is the difference between the Aid flow (current US$) in Germany and Aid flow (current US$) in Japan?
Offer a terse response. -3.34e+06. In the year 1976, what is the difference between the Aid flow (current US$) in Italy and Aid flow (current US$) in Japan?
Ensure brevity in your answer.  -7.82e+07. In the year 1977, what is the difference between the Aid flow (current US$) in France and Aid flow (current US$) in Germany?
Keep it short and to the point. -3.14e+07. In the year 1977, what is the difference between the Aid flow (current US$) in France and Aid flow (current US$) in Italy?
Provide a succinct answer. 2.66e+07. In the year 1977, what is the difference between the Aid flow (current US$) of France and Aid flow (current US$) of Japan?
Offer a terse response. -7.19e+06. In the year 1977, what is the difference between the Aid flow (current US$) in Germany and Aid flow (current US$) in Italy?
Your answer should be very brief. 5.80e+07. In the year 1977, what is the difference between the Aid flow (current US$) of Germany and Aid flow (current US$) of Japan?
Your response must be concise. 2.42e+07. In the year 1977, what is the difference between the Aid flow (current US$) in Italy and Aid flow (current US$) in Japan?
Ensure brevity in your answer.  -3.38e+07. In the year 1978, what is the difference between the Aid flow (current US$) of France and Aid flow (current US$) of Germany?
Ensure brevity in your answer.  -3.03e+07. In the year 1978, what is the difference between the Aid flow (current US$) in France and Aid flow (current US$) in Italy?
Give a very brief answer. 1.45e+07. In the year 1978, what is the difference between the Aid flow (current US$) of France and Aid flow (current US$) of Japan?
Offer a very short reply. -1.27e+07. In the year 1978, what is the difference between the Aid flow (current US$) in Germany and Aid flow (current US$) in Italy?
Your answer should be compact. 4.48e+07. In the year 1978, what is the difference between the Aid flow (current US$) of Germany and Aid flow (current US$) of Japan?
Offer a very short reply. 1.76e+07. In the year 1978, what is the difference between the Aid flow (current US$) in Italy and Aid flow (current US$) in Japan?
Provide a succinct answer. -2.72e+07. In the year 1979, what is the difference between the Aid flow (current US$) in France and Aid flow (current US$) in Germany?
Your response must be concise. -4.19e+07. In the year 1979, what is the difference between the Aid flow (current US$) in France and Aid flow (current US$) in Japan?
Ensure brevity in your answer.  -2.05e+07. In the year 1979, what is the difference between the Aid flow (current US$) of Germany and Aid flow (current US$) of Japan?
Ensure brevity in your answer.  2.14e+07. In the year 1980, what is the difference between the Aid flow (current US$) in France and Aid flow (current US$) in Germany?
Your answer should be very brief. -4.38e+07. In the year 1980, what is the difference between the Aid flow (current US$) in France and Aid flow (current US$) in Italy?
Offer a very short reply. 8.67e+06. In the year 1980, what is the difference between the Aid flow (current US$) in France and Aid flow (current US$) in Japan?
Provide a short and direct response. -1.03e+07. In the year 1980, what is the difference between the Aid flow (current US$) in Germany and Aid flow (current US$) in Italy?
Your answer should be very brief. 5.25e+07. In the year 1980, what is the difference between the Aid flow (current US$) in Germany and Aid flow (current US$) in Japan?
Make the answer very short. 3.36e+07. In the year 1980, what is the difference between the Aid flow (current US$) of Italy and Aid flow (current US$) of Japan?
Your answer should be very brief. -1.89e+07. In the year 1981, what is the difference between the Aid flow (current US$) of France and Aid flow (current US$) of Germany?
Keep it short and to the point. -2.80e+07. In the year 1981, what is the difference between the Aid flow (current US$) of France and Aid flow (current US$) of Italy?
Provide a succinct answer. 2.43e+07. In the year 1981, what is the difference between the Aid flow (current US$) of France and Aid flow (current US$) of Japan?
Provide a short and direct response. -3.76e+07. In the year 1981, what is the difference between the Aid flow (current US$) in Germany and Aid flow (current US$) in Italy?
Provide a succinct answer. 5.23e+07. In the year 1981, what is the difference between the Aid flow (current US$) in Germany and Aid flow (current US$) in Japan?
Your answer should be very brief. -9.54e+06. In the year 1981, what is the difference between the Aid flow (current US$) of Italy and Aid flow (current US$) of Japan?
Give a very brief answer. -6.19e+07. In the year 1982, what is the difference between the Aid flow (current US$) of France and Aid flow (current US$) of Germany?
Provide a succinct answer. -3.04e+07. In the year 1982, what is the difference between the Aid flow (current US$) in France and Aid flow (current US$) in Japan?
Your response must be concise. -3.54e+07. In the year 1982, what is the difference between the Aid flow (current US$) of Germany and Aid flow (current US$) of Japan?
Your response must be concise. -4.91e+06. What is the ratio of the Aid flow (current US$) in France in 1974 to that in 1975?
Make the answer very short. 0.55. What is the ratio of the Aid flow (current US$) in Germany in 1974 to that in 1975?
Your answer should be very brief. 0.81. What is the ratio of the Aid flow (current US$) in Italy in 1974 to that in 1975?
Provide a short and direct response. 0. What is the ratio of the Aid flow (current US$) in Japan in 1974 to that in 1975?
Ensure brevity in your answer.  1.23. What is the ratio of the Aid flow (current US$) of France in 1974 to that in 1976?
Give a very brief answer. 0.48. What is the ratio of the Aid flow (current US$) of Germany in 1974 to that in 1976?
Provide a succinct answer. 0.67. What is the ratio of the Aid flow (current US$) of Italy in 1974 to that in 1976?
Give a very brief answer. 0.1. What is the ratio of the Aid flow (current US$) of Japan in 1974 to that in 1976?
Ensure brevity in your answer.  0.63. What is the ratio of the Aid flow (current US$) in France in 1974 to that in 1977?
Your answer should be very brief. 0.74. What is the ratio of the Aid flow (current US$) of Germany in 1974 to that in 1977?
Provide a succinct answer. 0.87. What is the ratio of the Aid flow (current US$) of Italy in 1974 to that in 1977?
Offer a very short reply. 0.2. What is the ratio of the Aid flow (current US$) in Japan in 1974 to that in 1977?
Keep it short and to the point. 1.46. What is the ratio of the Aid flow (current US$) in France in 1974 to that in 1978?
Offer a terse response. 0.99. What is the ratio of the Aid flow (current US$) of Germany in 1974 to that in 1978?
Your response must be concise. 1. What is the ratio of the Aid flow (current US$) in Italy in 1974 to that in 1978?
Make the answer very short. 0. What is the ratio of the Aid flow (current US$) of Japan in 1974 to that in 1978?
Your answer should be compact. 1.51. What is the ratio of the Aid flow (current US$) of France in 1974 to that in 1979?
Offer a very short reply. 1.52. What is the ratio of the Aid flow (current US$) of Germany in 1974 to that in 1979?
Ensure brevity in your answer.  0.92. What is the ratio of the Aid flow (current US$) of Japan in 1974 to that in 1979?
Your answer should be compact. 1.47. What is the ratio of the Aid flow (current US$) in France in 1974 to that in 1980?
Your response must be concise. 1.2. What is the ratio of the Aid flow (current US$) of Germany in 1974 to that in 1980?
Offer a very short reply. 0.84. What is the ratio of the Aid flow (current US$) in Italy in 1974 to that in 1980?
Provide a succinct answer. 0. What is the ratio of the Aid flow (current US$) of Japan in 1974 to that in 1980?
Offer a terse response. 1.85. What is the ratio of the Aid flow (current US$) in France in 1974 to that in 1981?
Make the answer very short. 0.63. What is the ratio of the Aid flow (current US$) of Germany in 1974 to that in 1981?
Provide a succinct answer. 0.85. What is the ratio of the Aid flow (current US$) in Italy in 1974 to that in 1981?
Your answer should be compact. 0. What is the ratio of the Aid flow (current US$) of Japan in 1974 to that in 1981?
Offer a very short reply. 0.72. What is the ratio of the Aid flow (current US$) of France in 1974 to that in 1982?
Provide a short and direct response. 0.67. What is the ratio of the Aid flow (current US$) of Germany in 1974 to that in 1982?
Your answer should be compact. 0.84. What is the ratio of the Aid flow (current US$) of Japan in 1974 to that in 1982?
Your answer should be very brief. 0.76. What is the ratio of the Aid flow (current US$) in France in 1975 to that in 1976?
Provide a succinct answer. 0.88. What is the ratio of the Aid flow (current US$) in Germany in 1975 to that in 1976?
Your answer should be compact. 0.83. What is the ratio of the Aid flow (current US$) of Japan in 1975 to that in 1976?
Offer a terse response. 0.51. What is the ratio of the Aid flow (current US$) of France in 1975 to that in 1977?
Your answer should be compact. 1.35. What is the ratio of the Aid flow (current US$) of Germany in 1975 to that in 1977?
Give a very brief answer. 1.07. What is the ratio of the Aid flow (current US$) in Italy in 1975 to that in 1977?
Keep it short and to the point. 44.4. What is the ratio of the Aid flow (current US$) of Japan in 1975 to that in 1977?
Make the answer very short. 1.19. What is the ratio of the Aid flow (current US$) of France in 1975 to that in 1978?
Your answer should be very brief. 1.8. What is the ratio of the Aid flow (current US$) of Germany in 1975 to that in 1978?
Provide a succinct answer. 1.24. What is the ratio of the Aid flow (current US$) in Italy in 1975 to that in 1978?
Provide a succinct answer. 0.4. What is the ratio of the Aid flow (current US$) in Japan in 1975 to that in 1978?
Your answer should be compact. 1.23. What is the ratio of the Aid flow (current US$) of France in 1975 to that in 1979?
Your response must be concise. 2.77. What is the ratio of the Aid flow (current US$) in Germany in 1975 to that in 1979?
Ensure brevity in your answer.  1.13. What is the ratio of the Aid flow (current US$) in Japan in 1975 to that in 1979?
Provide a succinct answer. 1.2. What is the ratio of the Aid flow (current US$) of France in 1975 to that in 1980?
Provide a short and direct response. 2.2. What is the ratio of the Aid flow (current US$) in Germany in 1975 to that in 1980?
Ensure brevity in your answer.  1.03. What is the ratio of the Aid flow (current US$) of Italy in 1975 to that in 1980?
Your answer should be very brief. 0.29. What is the ratio of the Aid flow (current US$) of Japan in 1975 to that in 1980?
Provide a short and direct response. 1.51. What is the ratio of the Aid flow (current US$) of France in 1975 to that in 1981?
Give a very brief answer. 1.15. What is the ratio of the Aid flow (current US$) of Germany in 1975 to that in 1981?
Offer a terse response. 1.05. What is the ratio of the Aid flow (current US$) in Italy in 1975 to that in 1981?
Your response must be concise. 0.31. What is the ratio of the Aid flow (current US$) of Japan in 1975 to that in 1981?
Keep it short and to the point. 0.58. What is the ratio of the Aid flow (current US$) in France in 1975 to that in 1982?
Offer a terse response. 1.23. What is the ratio of the Aid flow (current US$) in Germany in 1975 to that in 1982?
Make the answer very short. 1.04. What is the ratio of the Aid flow (current US$) of Japan in 1975 to that in 1982?
Offer a terse response. 0.62. What is the ratio of the Aid flow (current US$) of France in 1976 to that in 1977?
Your answer should be very brief. 1.53. What is the ratio of the Aid flow (current US$) in Germany in 1976 to that in 1977?
Provide a short and direct response. 1.29. What is the ratio of the Aid flow (current US$) of Japan in 1976 to that in 1977?
Your answer should be compact. 2.31. What is the ratio of the Aid flow (current US$) in France in 1976 to that in 1978?
Keep it short and to the point. 2.04. What is the ratio of the Aid flow (current US$) in Germany in 1976 to that in 1978?
Your answer should be compact. 1.49. What is the ratio of the Aid flow (current US$) in Italy in 1976 to that in 1978?
Provide a succinct answer. 0.02. What is the ratio of the Aid flow (current US$) in Japan in 1976 to that in 1978?
Offer a terse response. 2.39. What is the ratio of the Aid flow (current US$) in France in 1976 to that in 1979?
Provide a short and direct response. 3.14. What is the ratio of the Aid flow (current US$) in Germany in 1976 to that in 1979?
Provide a succinct answer. 1.36. What is the ratio of the Aid flow (current US$) of Japan in 1976 to that in 1979?
Offer a very short reply. 2.33. What is the ratio of the Aid flow (current US$) of France in 1976 to that in 1980?
Offer a very short reply. 2.49. What is the ratio of the Aid flow (current US$) of Germany in 1976 to that in 1980?
Provide a succinct answer. 1.24. What is the ratio of the Aid flow (current US$) of Italy in 1976 to that in 1980?
Keep it short and to the point. 0.01. What is the ratio of the Aid flow (current US$) of Japan in 1976 to that in 1980?
Your response must be concise. 2.93. What is the ratio of the Aid flow (current US$) of France in 1976 to that in 1981?
Ensure brevity in your answer.  1.3. What is the ratio of the Aid flow (current US$) of Germany in 1976 to that in 1981?
Provide a succinct answer. 1.26. What is the ratio of the Aid flow (current US$) in Italy in 1976 to that in 1981?
Keep it short and to the point. 0.01. What is the ratio of the Aid flow (current US$) of Japan in 1976 to that in 1981?
Your answer should be very brief. 1.13. What is the ratio of the Aid flow (current US$) in France in 1976 to that in 1982?
Your answer should be very brief. 1.39. What is the ratio of the Aid flow (current US$) of Germany in 1976 to that in 1982?
Make the answer very short. 1.25. What is the ratio of the Aid flow (current US$) in Japan in 1976 to that in 1982?
Your response must be concise. 1.21. What is the ratio of the Aid flow (current US$) in France in 1977 to that in 1978?
Your answer should be compact. 1.33. What is the ratio of the Aid flow (current US$) of Germany in 1977 to that in 1978?
Provide a short and direct response. 1.15. What is the ratio of the Aid flow (current US$) of Italy in 1977 to that in 1978?
Keep it short and to the point. 0.01. What is the ratio of the Aid flow (current US$) of Japan in 1977 to that in 1978?
Keep it short and to the point. 1.04. What is the ratio of the Aid flow (current US$) of France in 1977 to that in 1979?
Your answer should be compact. 2.05. What is the ratio of the Aid flow (current US$) in Germany in 1977 to that in 1979?
Your response must be concise. 1.06. What is the ratio of the Aid flow (current US$) in Japan in 1977 to that in 1979?
Your response must be concise. 1.01. What is the ratio of the Aid flow (current US$) of France in 1977 to that in 1980?
Make the answer very short. 1.63. What is the ratio of the Aid flow (current US$) of Germany in 1977 to that in 1980?
Your answer should be compact. 0.96. What is the ratio of the Aid flow (current US$) of Italy in 1977 to that in 1980?
Offer a very short reply. 0.01. What is the ratio of the Aid flow (current US$) in Japan in 1977 to that in 1980?
Keep it short and to the point. 1.27. What is the ratio of the Aid flow (current US$) in France in 1977 to that in 1981?
Your answer should be very brief. 0.85. What is the ratio of the Aid flow (current US$) in Germany in 1977 to that in 1981?
Give a very brief answer. 0.98. What is the ratio of the Aid flow (current US$) of Italy in 1977 to that in 1981?
Provide a short and direct response. 0.01. What is the ratio of the Aid flow (current US$) in Japan in 1977 to that in 1981?
Provide a short and direct response. 0.49. What is the ratio of the Aid flow (current US$) of France in 1977 to that in 1982?
Keep it short and to the point. 0.91. What is the ratio of the Aid flow (current US$) in Germany in 1977 to that in 1982?
Offer a very short reply. 0.97. What is the ratio of the Aid flow (current US$) in Japan in 1977 to that in 1982?
Offer a very short reply. 0.52. What is the ratio of the Aid flow (current US$) in France in 1978 to that in 1979?
Ensure brevity in your answer.  1.54. What is the ratio of the Aid flow (current US$) of Germany in 1978 to that in 1979?
Ensure brevity in your answer.  0.92. What is the ratio of the Aid flow (current US$) of Japan in 1978 to that in 1979?
Your answer should be very brief. 0.98. What is the ratio of the Aid flow (current US$) in France in 1978 to that in 1980?
Give a very brief answer. 1.22. What is the ratio of the Aid flow (current US$) of Germany in 1978 to that in 1980?
Provide a short and direct response. 0.83. What is the ratio of the Aid flow (current US$) of Italy in 1978 to that in 1980?
Your answer should be very brief. 0.72. What is the ratio of the Aid flow (current US$) of Japan in 1978 to that in 1980?
Give a very brief answer. 1.23. What is the ratio of the Aid flow (current US$) of France in 1978 to that in 1981?
Provide a short and direct response. 0.64. What is the ratio of the Aid flow (current US$) of Germany in 1978 to that in 1981?
Your answer should be compact. 0.85. What is the ratio of the Aid flow (current US$) of Italy in 1978 to that in 1981?
Your response must be concise. 0.78. What is the ratio of the Aid flow (current US$) of Japan in 1978 to that in 1981?
Give a very brief answer. 0.47. What is the ratio of the Aid flow (current US$) of France in 1978 to that in 1982?
Offer a very short reply. 0.68. What is the ratio of the Aid flow (current US$) in Germany in 1978 to that in 1982?
Your answer should be compact. 0.84. What is the ratio of the Aid flow (current US$) of Japan in 1978 to that in 1982?
Provide a short and direct response. 0.51. What is the ratio of the Aid flow (current US$) of France in 1979 to that in 1980?
Offer a very short reply. 0.79. What is the ratio of the Aid flow (current US$) of Germany in 1979 to that in 1980?
Your answer should be compact. 0.91. What is the ratio of the Aid flow (current US$) of Japan in 1979 to that in 1980?
Your answer should be compact. 1.26. What is the ratio of the Aid flow (current US$) of France in 1979 to that in 1981?
Make the answer very short. 0.41. What is the ratio of the Aid flow (current US$) of Germany in 1979 to that in 1981?
Give a very brief answer. 0.92. What is the ratio of the Aid flow (current US$) in Japan in 1979 to that in 1981?
Your response must be concise. 0.49. What is the ratio of the Aid flow (current US$) of France in 1979 to that in 1982?
Your answer should be very brief. 0.44. What is the ratio of the Aid flow (current US$) in Germany in 1979 to that in 1982?
Your answer should be compact. 0.92. What is the ratio of the Aid flow (current US$) of Japan in 1979 to that in 1982?
Offer a terse response. 0.52. What is the ratio of the Aid flow (current US$) of France in 1980 to that in 1981?
Your answer should be compact. 0.52. What is the ratio of the Aid flow (current US$) of Germany in 1980 to that in 1981?
Keep it short and to the point. 1.01. What is the ratio of the Aid flow (current US$) in Italy in 1980 to that in 1981?
Give a very brief answer. 1.09. What is the ratio of the Aid flow (current US$) of Japan in 1980 to that in 1981?
Your answer should be very brief. 0.39. What is the ratio of the Aid flow (current US$) in France in 1980 to that in 1982?
Ensure brevity in your answer.  0.56. What is the ratio of the Aid flow (current US$) of Germany in 1980 to that in 1982?
Offer a very short reply. 1.01. What is the ratio of the Aid flow (current US$) of Japan in 1980 to that in 1982?
Ensure brevity in your answer.  0.41. What is the ratio of the Aid flow (current US$) of France in 1981 to that in 1982?
Provide a succinct answer. 1.07. What is the ratio of the Aid flow (current US$) of Germany in 1981 to that in 1982?
Give a very brief answer. 0.99. What is the ratio of the Aid flow (current US$) in Japan in 1981 to that in 1982?
Offer a terse response. 1.07. What is the difference between the highest and the second highest Aid flow (current US$) in France?
Offer a terse response. 4.83e+06. What is the difference between the highest and the second highest Aid flow (current US$) in Germany?
Your answer should be compact. 1.26e+07. What is the difference between the highest and the second highest Aid flow (current US$) of Italy?
Your response must be concise. 6.20e+05. What is the difference between the highest and the second highest Aid flow (current US$) of Japan?
Your answer should be compact. 9.29e+06. What is the difference between the highest and the lowest Aid flow (current US$) of France?
Your response must be concise. 2.79e+07. What is the difference between the highest and the lowest Aid flow (current US$) in Germany?
Your answer should be very brief. 2.46e+07. What is the difference between the highest and the lowest Aid flow (current US$) in Italy?
Offer a very short reply. 7.73e+06. What is the difference between the highest and the lowest Aid flow (current US$) of Japan?
Make the answer very short. 5.16e+07. 